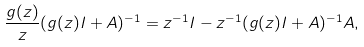Convert formula to latex. <formula><loc_0><loc_0><loc_500><loc_500>\frac { g ( z ) } { z } ( g ( z ) I + A ) ^ { - 1 } = z ^ { - 1 } I - z ^ { - 1 } ( g ( z ) I + A ) ^ { - 1 } A ,</formula> 